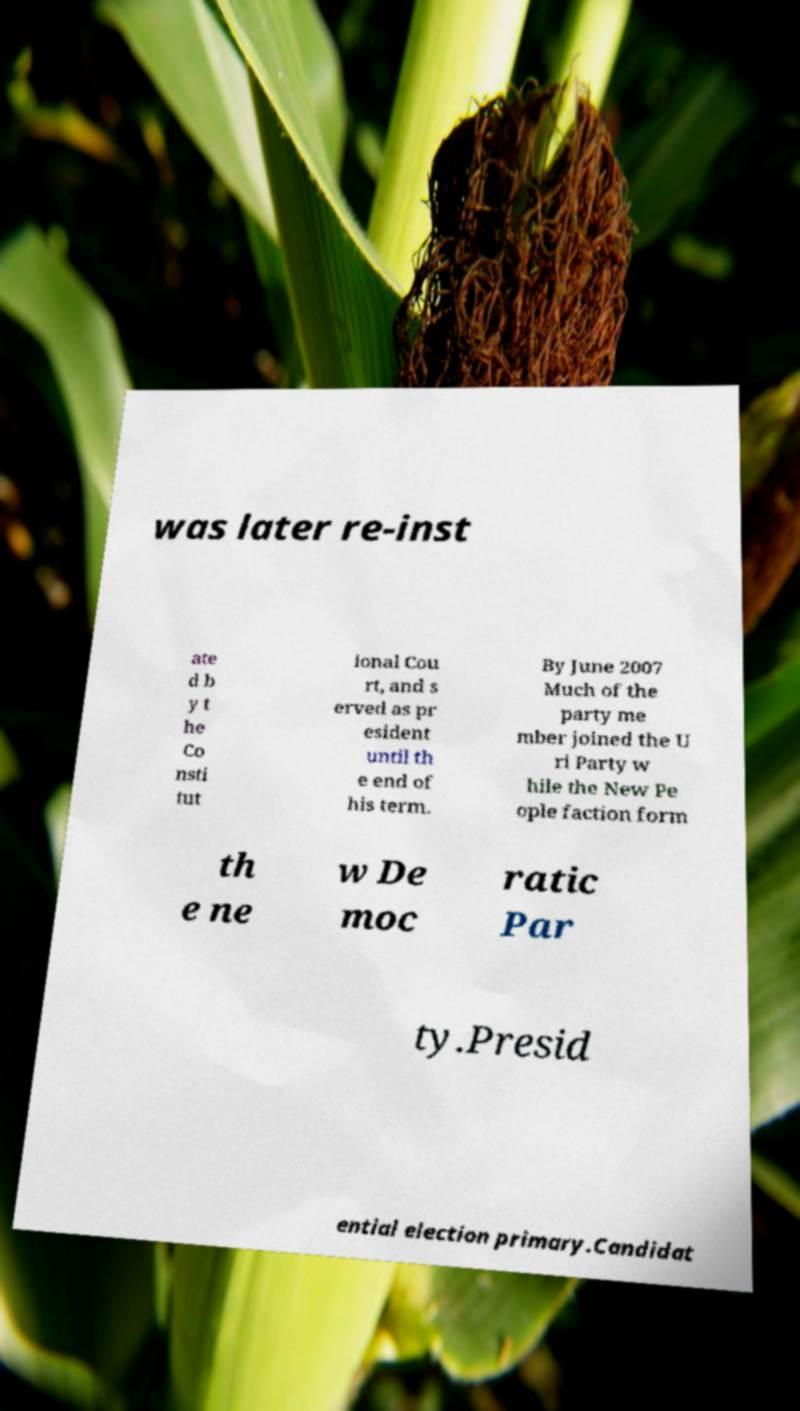Can you accurately transcribe the text from the provided image for me? was later re-inst ate d b y t he Co nsti tut ional Cou rt, and s erved as pr esident until th e end of his term. By June 2007 Much of the party me mber joined the U ri Party w hile the New Pe ople faction form th e ne w De moc ratic Par ty.Presid ential election primary.Candidat 